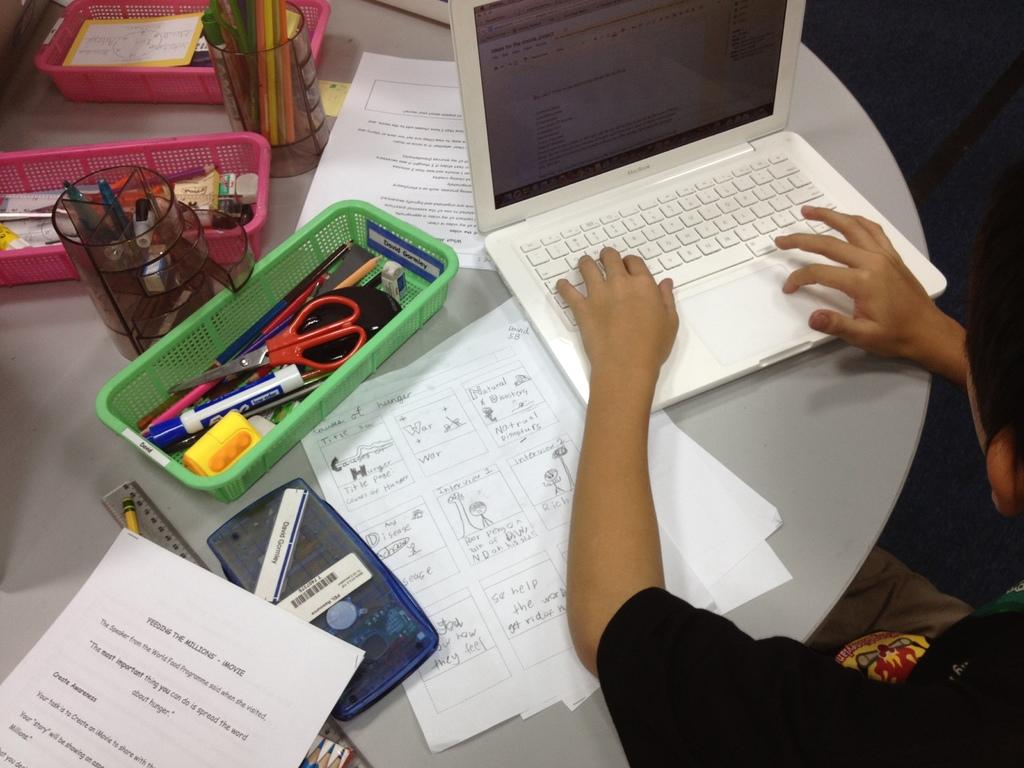<image>
Render a clear and concise summary of the photo. the word movie is on the white paper 